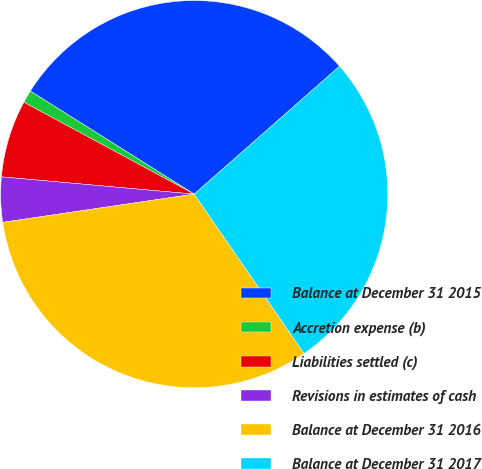Convert chart to OTSL. <chart><loc_0><loc_0><loc_500><loc_500><pie_chart><fcel>Balance at December 31 2015<fcel>Accretion expense (b)<fcel>Liabilities settled (c)<fcel>Revisions in estimates of cash<fcel>Balance at December 31 2016<fcel>Balance at December 31 2017<nl><fcel>29.58%<fcel>1.06%<fcel>6.45%<fcel>3.75%<fcel>32.28%<fcel>26.88%<nl></chart> 